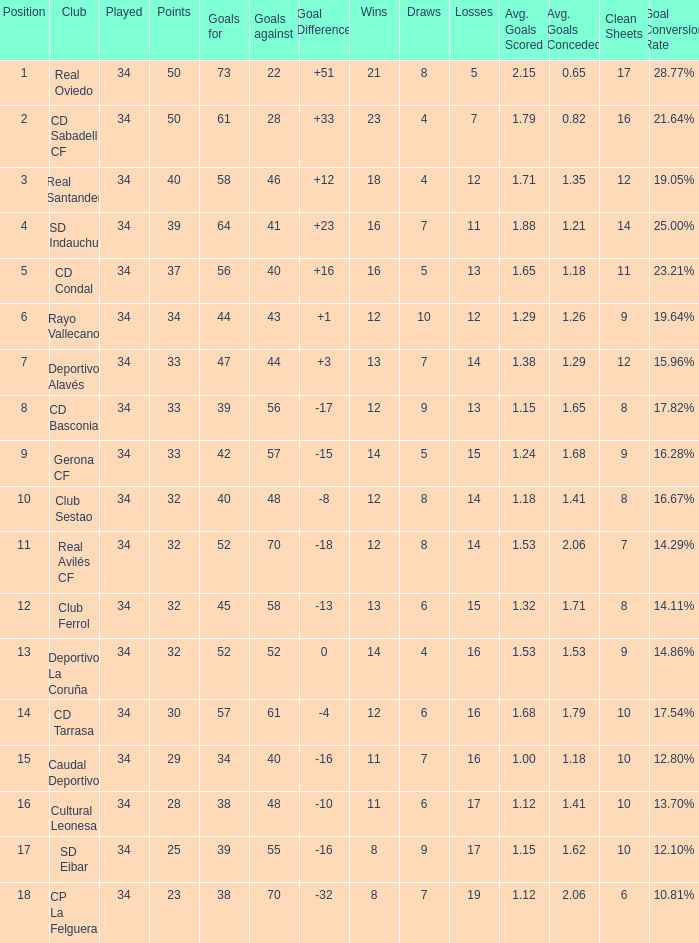Which Losses have a Goal Difference of -16, and less than 8 wins? None. 